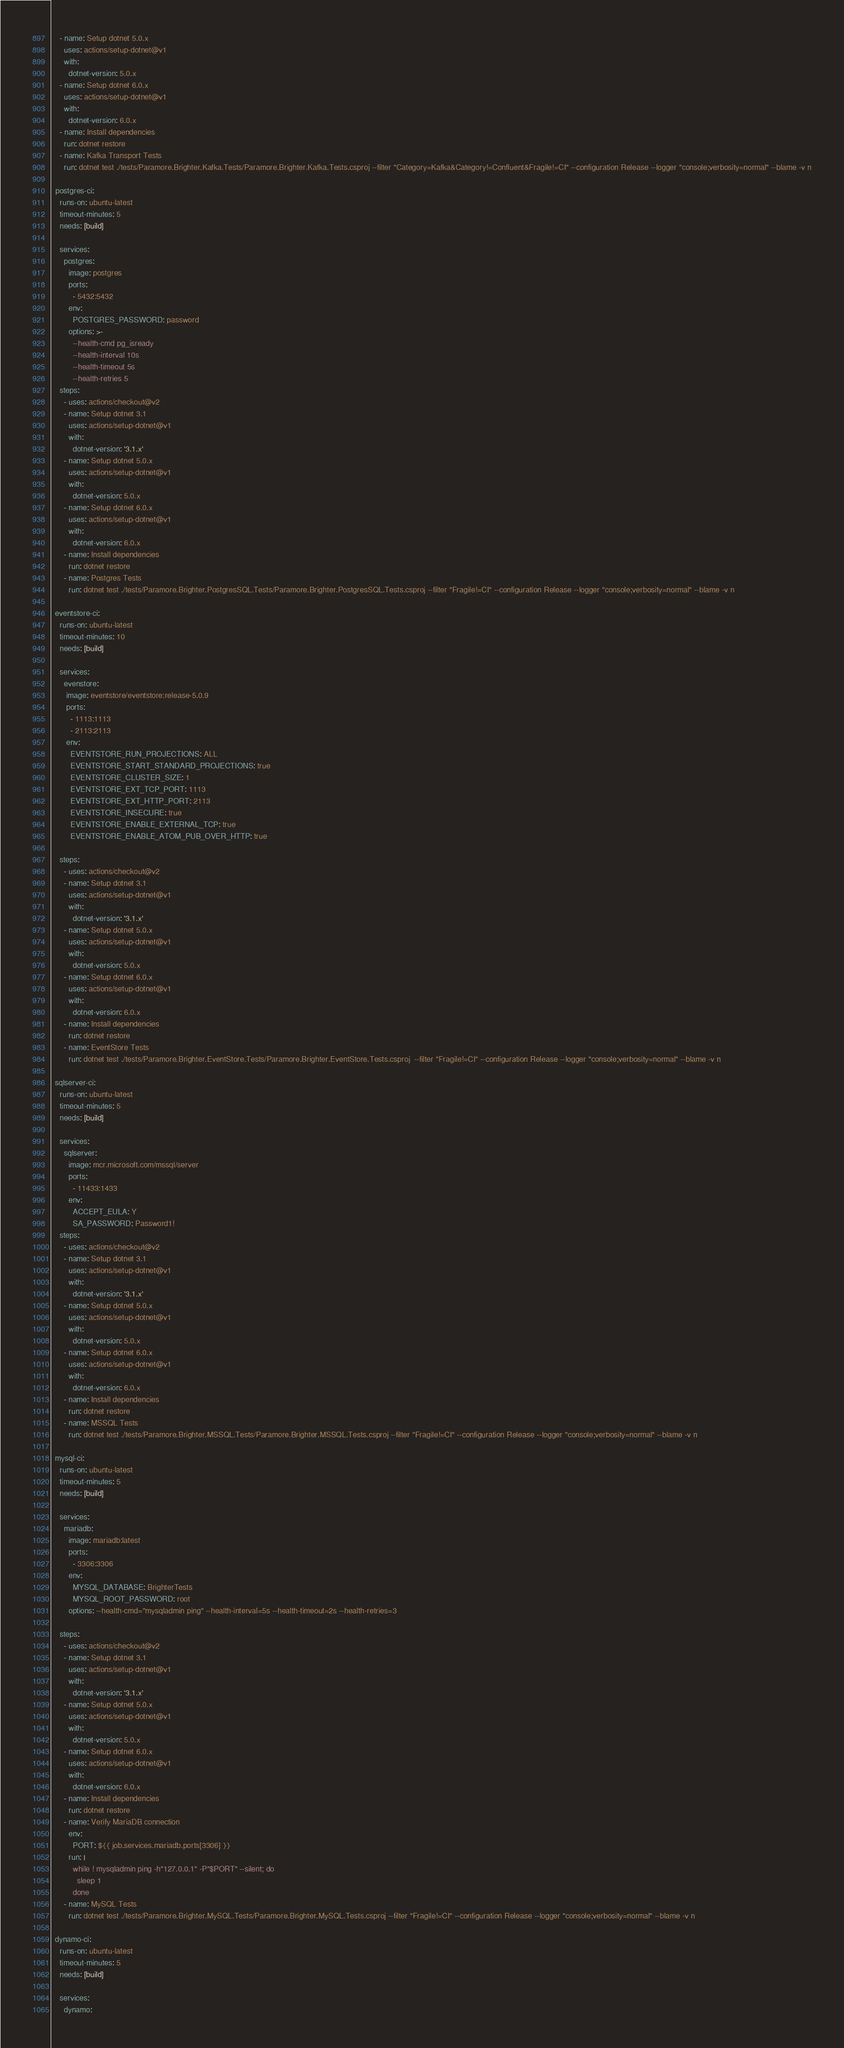Convert code to text. <code><loc_0><loc_0><loc_500><loc_500><_YAML_>    - name: Setup dotnet 5.0.x
      uses: actions/setup-dotnet@v1
      with:
        dotnet-version: 5.0.x
    - name: Setup dotnet 6.0.x
      uses: actions/setup-dotnet@v1
      with:
        dotnet-version: 6.0.x
    - name: Install dependencies
      run: dotnet restore
    - name: Kafka Transport Tests
      run: dotnet test ./tests/Paramore.Brighter.Kafka.Tests/Paramore.Brighter.Kafka.Tests.csproj --filter "Category=Kafka&Category!=Confluent&Fragile!=CI" --configuration Release --logger "console;verbosity=normal" --blame -v n
 
  postgres-ci:
    runs-on: ubuntu-latest
    timeout-minutes: 5
    needs: [build]
  
    services:
      postgres:
        image: postgres
        ports: 
          - 5432:5432
        env:
          POSTGRES_PASSWORD: password
        options: >-
          --health-cmd pg_isready
          --health-interval 10s
          --health-timeout 5s
          --health-retries 5
    steps:
      - uses: actions/checkout@v2
      - name: Setup dotnet 3.1
        uses: actions/setup-dotnet@v1
        with:
          dotnet-version: '3.1.x'
      - name: Setup dotnet 5.0.x
        uses: actions/setup-dotnet@v1
        with:
          dotnet-version: 5.0.x
      - name: Setup dotnet 6.0.x
        uses: actions/setup-dotnet@v1
        with:
          dotnet-version: 6.0.x
      - name: Install dependencies
        run: dotnet restore
      - name: Postgres Tests
        run: dotnet test ./tests/Paramore.Brighter.PostgresSQL.Tests/Paramore.Brighter.PostgresSQL.Tests.csproj --filter "Fragile!=CI" --configuration Release --logger "console;verbosity=normal" --blame -v n
        
  eventstore-ci:
    runs-on: ubuntu-latest
    timeout-minutes: 10
    needs: [build]
    
    services:
      evenstore: 
       image: eventstore/eventstore:release-5.0.9
       ports: 
         - 1113:1113
         - 2113:2113
       env:
         EVENTSTORE_RUN_PROJECTIONS: ALL
         EVENTSTORE_START_STANDARD_PROJECTIONS: true
         EVENTSTORE_CLUSTER_SIZE: 1
         EVENTSTORE_EXT_TCP_PORT: 1113
         EVENTSTORE_EXT_HTTP_PORT: 2113 
         EVENTSTORE_INSECURE: true
         EVENTSTORE_ENABLE_EXTERNAL_TCP: true
         EVENTSTORE_ENABLE_ATOM_PUB_OVER_HTTP: true   
     
    steps:
      - uses: actions/checkout@v2
      - name: Setup dotnet 3.1
        uses: actions/setup-dotnet@v1
        with:
          dotnet-version: '3.1.x'
      - name: Setup dotnet 5.0.x
        uses: actions/setup-dotnet@v1
        with:
          dotnet-version: 5.0.x
      - name: Setup dotnet 6.0.x
        uses: actions/setup-dotnet@v1
        with:
          dotnet-version: 6.0.x
      - name: Install dependencies
        run: dotnet restore
      - name: EventStore Tests
        run: dotnet test ./tests/Paramore.Brighter.EventStore.Tests/Paramore.Brighter.EventStore.Tests.csproj  --filter "Fragile!=CI" --configuration Release --logger "console;verbosity=normal" --blame -v n
  
  sqlserver-ci:
    runs-on: ubuntu-latest
    timeout-minutes: 5
    needs: [build]
  
    services:
      sqlserver:
        image: mcr.microsoft.com/mssql/server
        ports: 
          - 11433:1433
        env:
          ACCEPT_EULA: Y
          SA_PASSWORD: Password1!
    steps:
      - uses: actions/checkout@v2
      - name: Setup dotnet 3.1
        uses: actions/setup-dotnet@v1
        with:
          dotnet-version: '3.1.x'
      - name: Setup dotnet 5.0.x
        uses: actions/setup-dotnet@v1
        with:
          dotnet-version: 5.0.x
      - name: Setup dotnet 6.0.x
        uses: actions/setup-dotnet@v1
        with:
          dotnet-version: 6.0.x
      - name: Install dependencies
        run: dotnet restore
      - name: MSSQL Tests
        run: dotnet test ./tests/Paramore.Brighter.MSSQL.Tests/Paramore.Brighter.MSSQL.Tests.csproj --filter "Fragile!=CI" --configuration Release --logger "console;verbosity=normal" --blame -v n
        
  mysql-ci:
    runs-on: ubuntu-latest
    timeout-minutes: 5
    needs: [build]
  
    services:
      mariadb:
        image: mariadb:latest
        ports:
          - 3306:3306
        env:
          MYSQL_DATABASE: BrighterTests
          MYSQL_ROOT_PASSWORD: root
        options: --health-cmd="mysqladmin ping" --health-interval=5s --health-timeout=2s --health-retries=3

    steps:
      - uses: actions/checkout@v2
      - name: Setup dotnet 3.1
        uses: actions/setup-dotnet@v1
        with:
          dotnet-version: '3.1.x'
      - name: Setup dotnet 5.0.x
        uses: actions/setup-dotnet@v1
        with:
          dotnet-version: 5.0.x
      - name: Setup dotnet 6.0.x
        uses: actions/setup-dotnet@v1
        with:
          dotnet-version: 6.0.x
      - name: Install dependencies
        run: dotnet restore
      - name: Verify MariaDB connection
        env:
          PORT: ${{ job.services.mariadb.ports[3306] }}
        run: |
          while ! mysqladmin ping -h"127.0.0.1" -P"$PORT" --silent; do
            sleep 1
          done
      - name: MySQL Tests
        run: dotnet test ./tests/Paramore.Brighter.MySQL.Tests/Paramore.Brighter.MySQL.Tests.csproj --filter "Fragile!=CI" --configuration Release --logger "console;verbosity=normal" --blame -v n

  dynamo-ci:
    runs-on: ubuntu-latest
    timeout-minutes: 5
    needs: [build]
  
    services:
      dynamo:</code> 